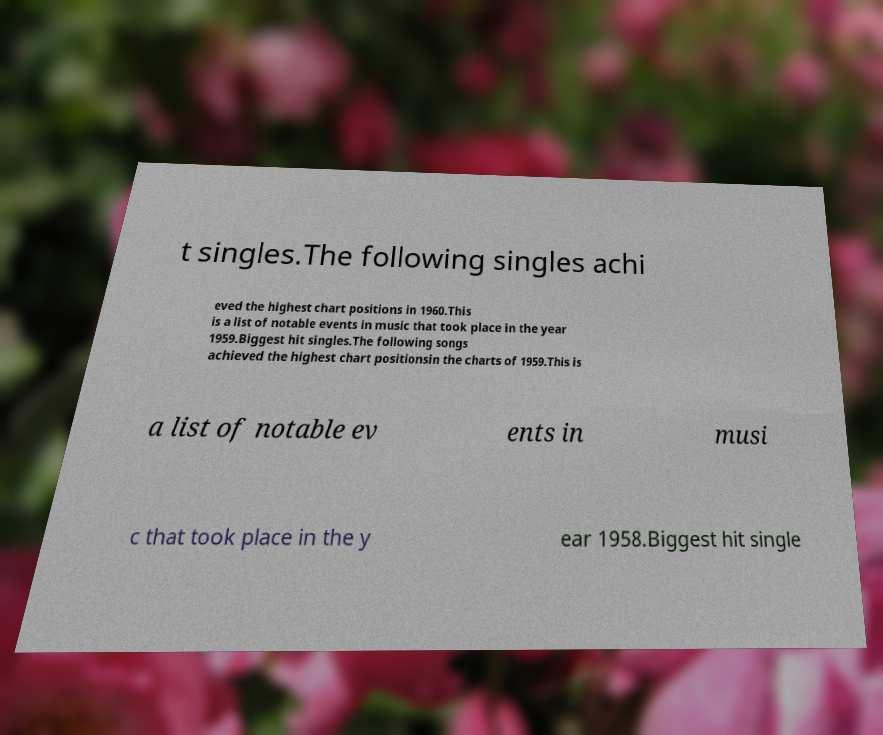What messages or text are displayed in this image? I need them in a readable, typed format. t singles.The following singles achi eved the highest chart positions in 1960.This is a list of notable events in music that took place in the year 1959.Biggest hit singles.The following songs achieved the highest chart positionsin the charts of 1959.This is a list of notable ev ents in musi c that took place in the y ear 1958.Biggest hit single 